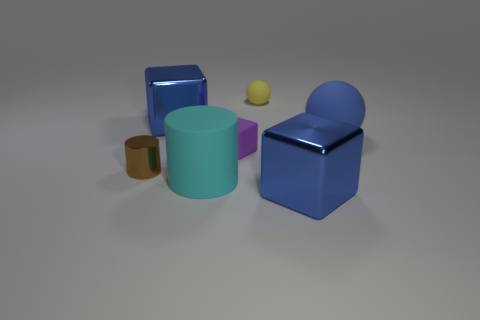Are there any rubber objects behind the tiny purple rubber object?
Your answer should be very brief. Yes. There is a rubber object that is the same shape as the brown metallic thing; what size is it?
Provide a short and direct response. Large. Are there an equal number of objects that are in front of the cyan matte cylinder and small yellow spheres that are in front of the large blue matte object?
Provide a short and direct response. No. How many spheres are there?
Offer a very short reply. 2. Are there more blue spheres that are to the right of the blue matte object than big cylinders?
Your answer should be compact. No. There is a large blue object left of the small purple block; what material is it?
Provide a succinct answer. Metal. What color is the large object that is the same shape as the small yellow thing?
Ensure brevity in your answer.  Blue. How many big metallic objects are the same color as the rubber block?
Offer a very short reply. 0. Do the blue metal cube in front of the metal cylinder and the yellow matte thing that is right of the metallic cylinder have the same size?
Your answer should be compact. No. Does the blue rubber thing have the same size as the shiny thing that is right of the cyan matte cylinder?
Your answer should be compact. Yes. 